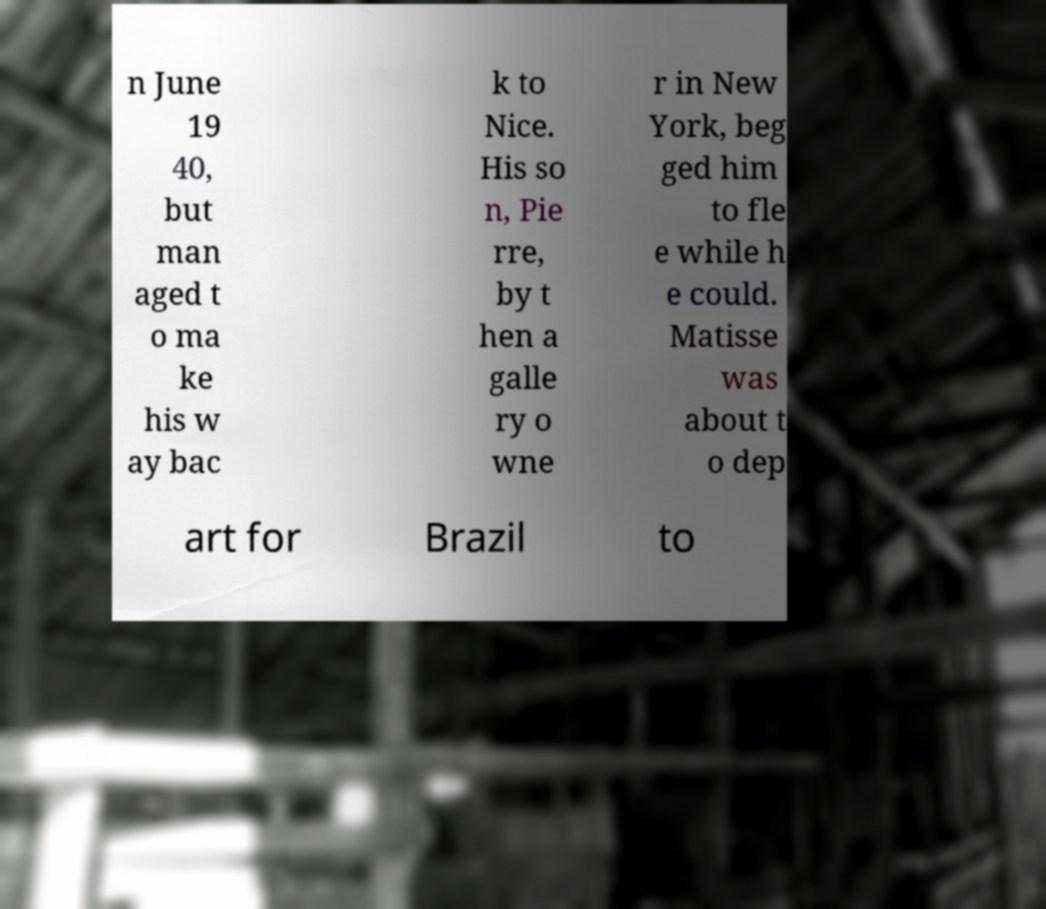There's text embedded in this image that I need extracted. Can you transcribe it verbatim? n June 19 40, but man aged t o ma ke his w ay bac k to Nice. His so n, Pie rre, by t hen a galle ry o wne r in New York, beg ged him to fle e while h e could. Matisse was about t o dep art for Brazil to 